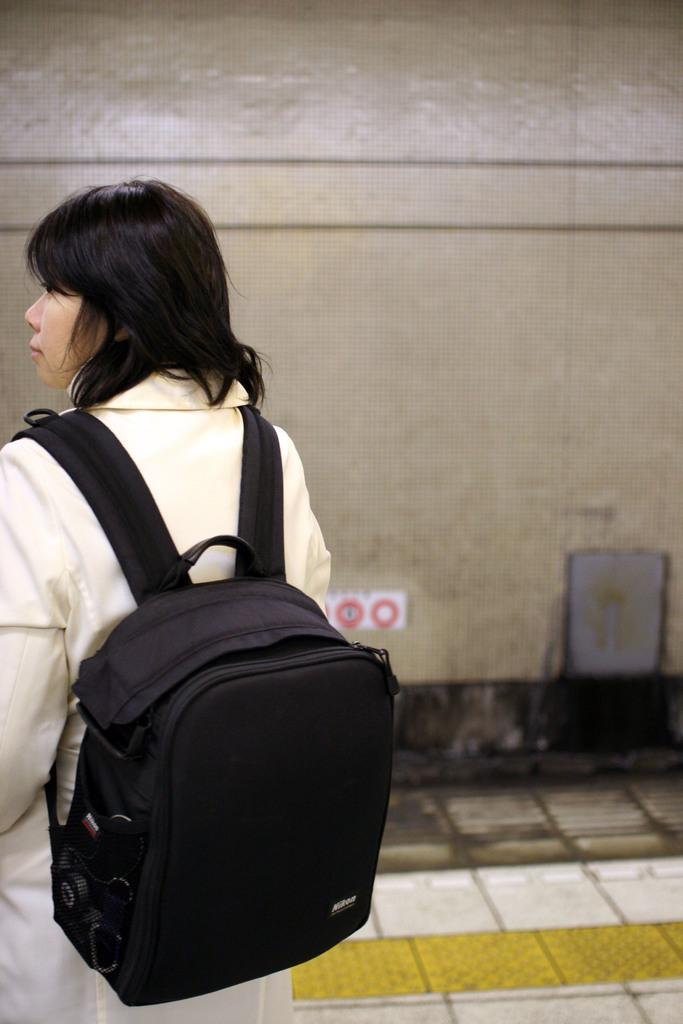Who is present in the image? There is a woman in the image. What is the woman holding or carrying? The woman is carrying a bag. What can be seen behind the woman? There is a wall behind the woman. Is the woman using a yoke to carry the bag in the image? There is no yoke present in the image, and the woman is not using one to carry the bag. 